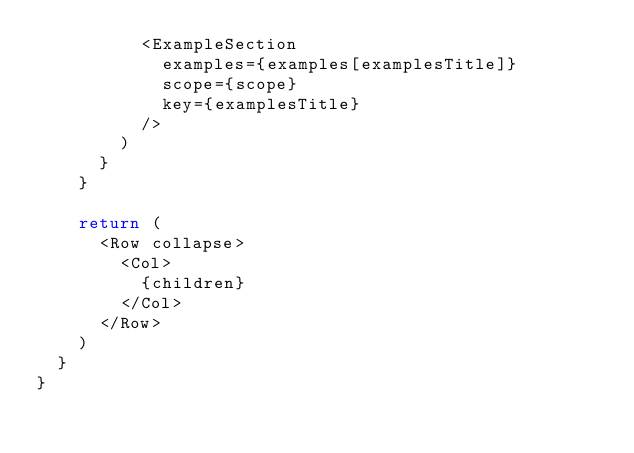Convert code to text. <code><loc_0><loc_0><loc_500><loc_500><_JavaScript_>          <ExampleSection
            examples={examples[examplesTitle]}
            scope={scope}
            key={examplesTitle}
          />
        )
      }
    }

    return (
      <Row collapse>
        <Col>
          {children}
        </Col>
      </Row>
    )
  }
}
</code> 